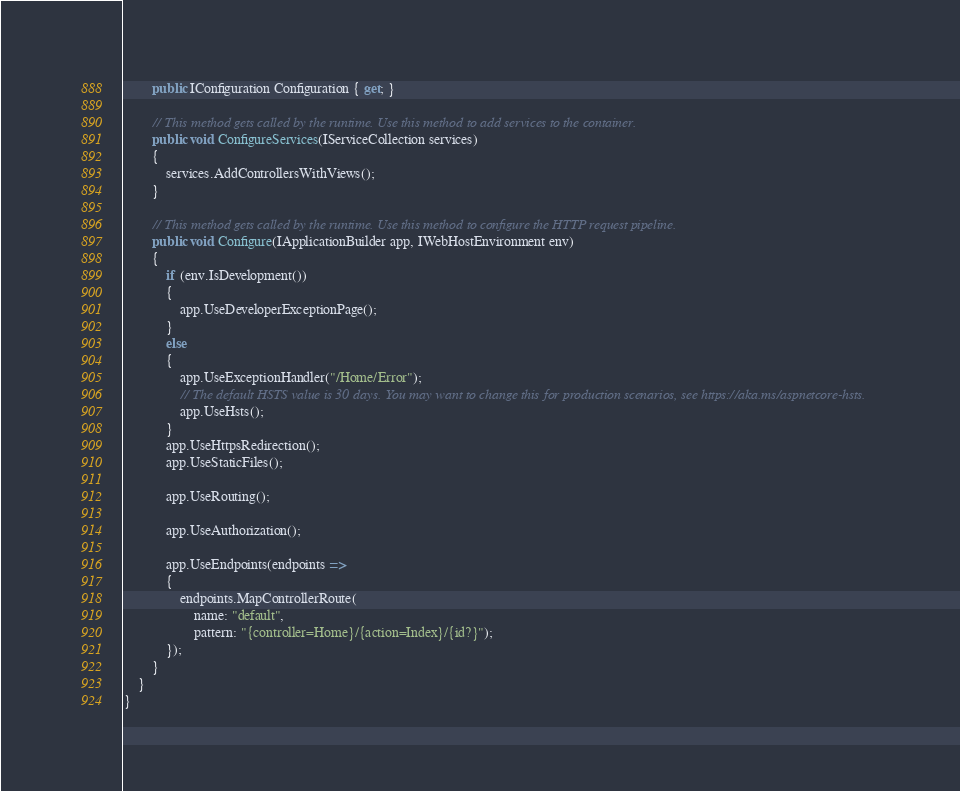Convert code to text. <code><loc_0><loc_0><loc_500><loc_500><_C#_>        public IConfiguration Configuration { get; }

        // This method gets called by the runtime. Use this method to add services to the container.
        public void ConfigureServices(IServiceCollection services)
        {
            services.AddControllersWithViews();
        }

        // This method gets called by the runtime. Use this method to configure the HTTP request pipeline.
        public void Configure(IApplicationBuilder app, IWebHostEnvironment env)
        {
            if (env.IsDevelopment())
            {
                app.UseDeveloperExceptionPage();
            }
            else
            {
                app.UseExceptionHandler("/Home/Error");
                // The default HSTS value is 30 days. You may want to change this for production scenarios, see https://aka.ms/aspnetcore-hsts.
                app.UseHsts();
            }
            app.UseHttpsRedirection();
            app.UseStaticFiles();

            app.UseRouting();

            app.UseAuthorization();

            app.UseEndpoints(endpoints =>
            {
                endpoints.MapControllerRoute(
                    name: "default",
                    pattern: "{controller=Home}/{action=Index}/{id?}");
            });
        }
    }
}
</code> 